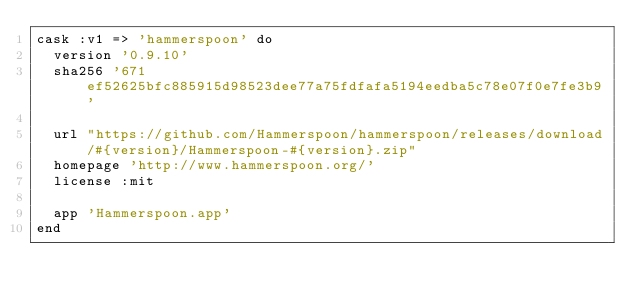Convert code to text. <code><loc_0><loc_0><loc_500><loc_500><_Ruby_>cask :v1 => 'hammerspoon' do
  version '0.9.10'
  sha256 '671ef52625bfc885915d98523dee77a75fdfafa5194eedba5c78e07f0e7fe3b9'

  url "https://github.com/Hammerspoon/hammerspoon/releases/download/#{version}/Hammerspoon-#{version}.zip"
  homepage 'http://www.hammerspoon.org/'
  license :mit

  app 'Hammerspoon.app'
end
</code> 